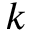Convert formula to latex. <formula><loc_0><loc_0><loc_500><loc_500>k</formula> 